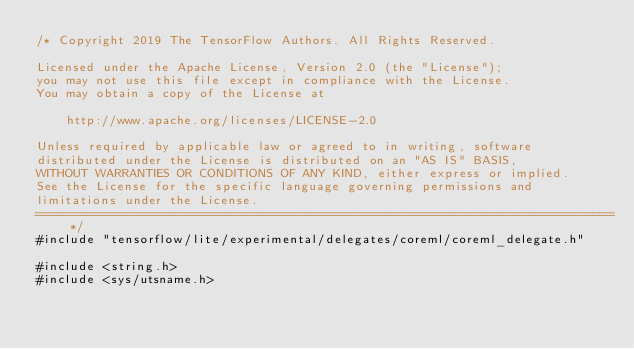Convert code to text. <code><loc_0><loc_0><loc_500><loc_500><_ObjectiveC_>/* Copyright 2019 The TensorFlow Authors. All Rights Reserved.

Licensed under the Apache License, Version 2.0 (the "License");
you may not use this file except in compliance with the License.
You may obtain a copy of the License at

    http://www.apache.org/licenses/LICENSE-2.0

Unless required by applicable law or agreed to in writing, software
distributed under the License is distributed on an "AS IS" BASIS,
WITHOUT WARRANTIES OR CONDITIONS OF ANY KIND, either express or implied.
See the License for the specific language governing permissions and
limitations under the License.
==============================================================================*/
#include "tensorflow/lite/experimental/delegates/coreml/coreml_delegate.h"

#include <string.h>
#include <sys/utsname.h></code> 